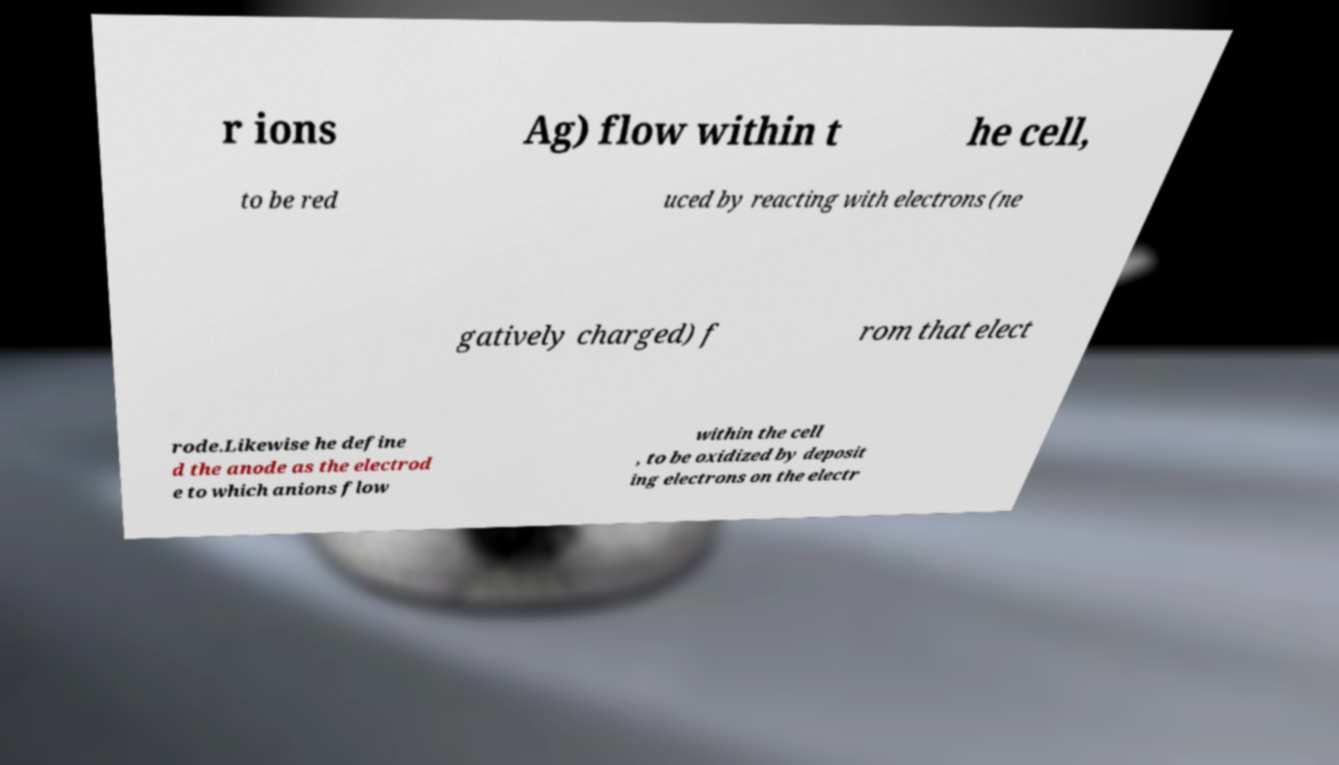Can you accurately transcribe the text from the provided image for me? r ions Ag) flow within t he cell, to be red uced by reacting with electrons (ne gatively charged) f rom that elect rode.Likewise he define d the anode as the electrod e to which anions flow within the cell , to be oxidized by deposit ing electrons on the electr 